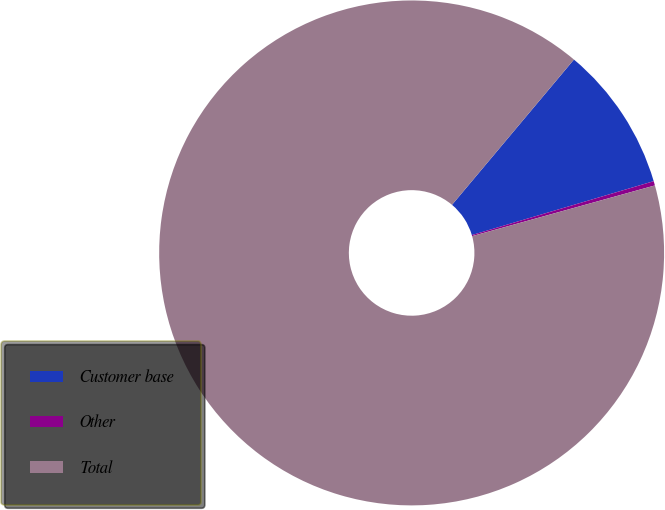Convert chart to OTSL. <chart><loc_0><loc_0><loc_500><loc_500><pie_chart><fcel>Customer base<fcel>Other<fcel>Total<nl><fcel>9.3%<fcel>0.28%<fcel>90.42%<nl></chart> 